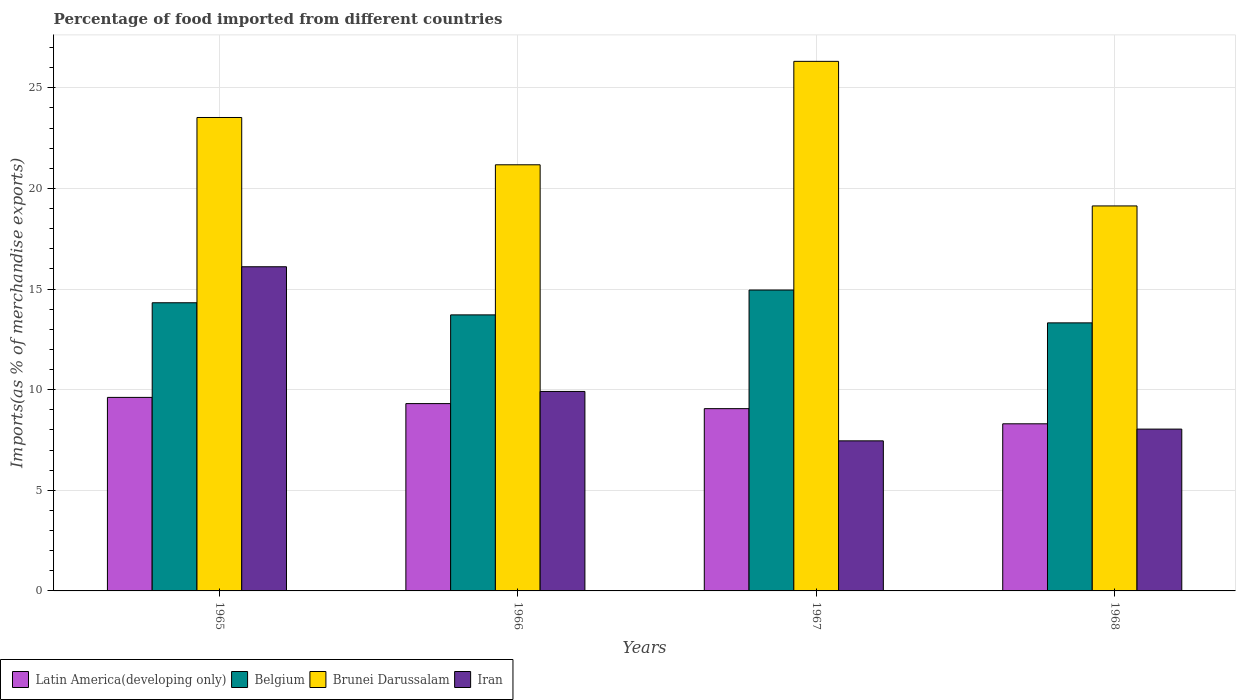How many different coloured bars are there?
Provide a succinct answer. 4. How many groups of bars are there?
Make the answer very short. 4. Are the number of bars on each tick of the X-axis equal?
Your response must be concise. Yes. How many bars are there on the 4th tick from the left?
Keep it short and to the point. 4. How many bars are there on the 4th tick from the right?
Your response must be concise. 4. What is the label of the 3rd group of bars from the left?
Make the answer very short. 1967. In how many cases, is the number of bars for a given year not equal to the number of legend labels?
Offer a terse response. 0. What is the percentage of imports to different countries in Belgium in 1966?
Your response must be concise. 13.72. Across all years, what is the maximum percentage of imports to different countries in Brunei Darussalam?
Your response must be concise. 26.32. Across all years, what is the minimum percentage of imports to different countries in Brunei Darussalam?
Your answer should be very brief. 19.13. In which year was the percentage of imports to different countries in Latin America(developing only) maximum?
Your response must be concise. 1965. In which year was the percentage of imports to different countries in Belgium minimum?
Keep it short and to the point. 1968. What is the total percentage of imports to different countries in Latin America(developing only) in the graph?
Your answer should be very brief. 36.29. What is the difference between the percentage of imports to different countries in Brunei Darussalam in 1965 and that in 1967?
Give a very brief answer. -2.79. What is the difference between the percentage of imports to different countries in Latin America(developing only) in 1968 and the percentage of imports to different countries in Brunei Darussalam in 1967?
Make the answer very short. -18.01. What is the average percentage of imports to different countries in Brunei Darussalam per year?
Your answer should be very brief. 22.54. In the year 1965, what is the difference between the percentage of imports to different countries in Iran and percentage of imports to different countries in Belgium?
Offer a terse response. 1.79. What is the ratio of the percentage of imports to different countries in Brunei Darussalam in 1965 to that in 1966?
Make the answer very short. 1.11. What is the difference between the highest and the second highest percentage of imports to different countries in Belgium?
Keep it short and to the point. 0.63. What is the difference between the highest and the lowest percentage of imports to different countries in Iran?
Provide a short and direct response. 8.65. In how many years, is the percentage of imports to different countries in Belgium greater than the average percentage of imports to different countries in Belgium taken over all years?
Keep it short and to the point. 2. Is it the case that in every year, the sum of the percentage of imports to different countries in Belgium and percentage of imports to different countries in Iran is greater than the sum of percentage of imports to different countries in Latin America(developing only) and percentage of imports to different countries in Brunei Darussalam?
Ensure brevity in your answer.  No. What does the 3rd bar from the left in 1967 represents?
Your answer should be compact. Brunei Darussalam. What does the 4th bar from the right in 1965 represents?
Provide a short and direct response. Latin America(developing only). Is it the case that in every year, the sum of the percentage of imports to different countries in Iran and percentage of imports to different countries in Brunei Darussalam is greater than the percentage of imports to different countries in Belgium?
Your answer should be compact. Yes. What is the difference between two consecutive major ticks on the Y-axis?
Offer a terse response. 5. Does the graph contain any zero values?
Offer a terse response. No. How are the legend labels stacked?
Offer a very short reply. Horizontal. What is the title of the graph?
Give a very brief answer. Percentage of food imported from different countries. What is the label or title of the Y-axis?
Your answer should be compact. Imports(as % of merchandise exports). What is the Imports(as % of merchandise exports) of Latin America(developing only) in 1965?
Your answer should be compact. 9.62. What is the Imports(as % of merchandise exports) in Belgium in 1965?
Give a very brief answer. 14.32. What is the Imports(as % of merchandise exports) of Brunei Darussalam in 1965?
Your response must be concise. 23.53. What is the Imports(as % of merchandise exports) of Iran in 1965?
Provide a short and direct response. 16.11. What is the Imports(as % of merchandise exports) in Latin America(developing only) in 1966?
Provide a succinct answer. 9.31. What is the Imports(as % of merchandise exports) in Belgium in 1966?
Your answer should be compact. 13.72. What is the Imports(as % of merchandise exports) of Brunei Darussalam in 1966?
Your answer should be very brief. 21.18. What is the Imports(as % of merchandise exports) in Iran in 1966?
Your response must be concise. 9.91. What is the Imports(as % of merchandise exports) of Latin America(developing only) in 1967?
Your response must be concise. 9.06. What is the Imports(as % of merchandise exports) in Belgium in 1967?
Offer a very short reply. 14.95. What is the Imports(as % of merchandise exports) of Brunei Darussalam in 1967?
Ensure brevity in your answer.  26.32. What is the Imports(as % of merchandise exports) in Iran in 1967?
Ensure brevity in your answer.  7.46. What is the Imports(as % of merchandise exports) in Latin America(developing only) in 1968?
Ensure brevity in your answer.  8.3. What is the Imports(as % of merchandise exports) in Belgium in 1968?
Provide a succinct answer. 13.32. What is the Imports(as % of merchandise exports) in Brunei Darussalam in 1968?
Provide a succinct answer. 19.13. What is the Imports(as % of merchandise exports) of Iran in 1968?
Give a very brief answer. 8.04. Across all years, what is the maximum Imports(as % of merchandise exports) of Latin America(developing only)?
Make the answer very short. 9.62. Across all years, what is the maximum Imports(as % of merchandise exports) of Belgium?
Keep it short and to the point. 14.95. Across all years, what is the maximum Imports(as % of merchandise exports) in Brunei Darussalam?
Give a very brief answer. 26.32. Across all years, what is the maximum Imports(as % of merchandise exports) of Iran?
Offer a very short reply. 16.11. Across all years, what is the minimum Imports(as % of merchandise exports) of Latin America(developing only)?
Your answer should be very brief. 8.3. Across all years, what is the minimum Imports(as % of merchandise exports) of Belgium?
Your answer should be very brief. 13.32. Across all years, what is the minimum Imports(as % of merchandise exports) of Brunei Darussalam?
Offer a very short reply. 19.13. Across all years, what is the minimum Imports(as % of merchandise exports) in Iran?
Ensure brevity in your answer.  7.46. What is the total Imports(as % of merchandise exports) of Latin America(developing only) in the graph?
Provide a short and direct response. 36.29. What is the total Imports(as % of merchandise exports) of Belgium in the graph?
Your answer should be compact. 56.31. What is the total Imports(as % of merchandise exports) of Brunei Darussalam in the graph?
Offer a terse response. 90.15. What is the total Imports(as % of merchandise exports) in Iran in the graph?
Provide a short and direct response. 41.52. What is the difference between the Imports(as % of merchandise exports) of Latin America(developing only) in 1965 and that in 1966?
Offer a very short reply. 0.31. What is the difference between the Imports(as % of merchandise exports) in Belgium in 1965 and that in 1966?
Provide a short and direct response. 0.6. What is the difference between the Imports(as % of merchandise exports) of Brunei Darussalam in 1965 and that in 1966?
Give a very brief answer. 2.35. What is the difference between the Imports(as % of merchandise exports) in Iran in 1965 and that in 1966?
Your response must be concise. 6.2. What is the difference between the Imports(as % of merchandise exports) of Latin America(developing only) in 1965 and that in 1967?
Offer a very short reply. 0.56. What is the difference between the Imports(as % of merchandise exports) in Belgium in 1965 and that in 1967?
Your answer should be compact. -0.63. What is the difference between the Imports(as % of merchandise exports) in Brunei Darussalam in 1965 and that in 1967?
Make the answer very short. -2.79. What is the difference between the Imports(as % of merchandise exports) in Iran in 1965 and that in 1967?
Your answer should be compact. 8.65. What is the difference between the Imports(as % of merchandise exports) of Latin America(developing only) in 1965 and that in 1968?
Your response must be concise. 1.31. What is the difference between the Imports(as % of merchandise exports) of Belgium in 1965 and that in 1968?
Provide a short and direct response. 1. What is the difference between the Imports(as % of merchandise exports) of Brunei Darussalam in 1965 and that in 1968?
Keep it short and to the point. 4.39. What is the difference between the Imports(as % of merchandise exports) in Iran in 1965 and that in 1968?
Provide a succinct answer. 8.07. What is the difference between the Imports(as % of merchandise exports) of Latin America(developing only) in 1966 and that in 1967?
Provide a short and direct response. 0.25. What is the difference between the Imports(as % of merchandise exports) of Belgium in 1966 and that in 1967?
Keep it short and to the point. -1.24. What is the difference between the Imports(as % of merchandise exports) of Brunei Darussalam in 1966 and that in 1967?
Make the answer very short. -5.14. What is the difference between the Imports(as % of merchandise exports) of Iran in 1966 and that in 1967?
Give a very brief answer. 2.46. What is the difference between the Imports(as % of merchandise exports) of Belgium in 1966 and that in 1968?
Give a very brief answer. 0.4. What is the difference between the Imports(as % of merchandise exports) in Brunei Darussalam in 1966 and that in 1968?
Ensure brevity in your answer.  2.04. What is the difference between the Imports(as % of merchandise exports) of Iran in 1966 and that in 1968?
Your answer should be compact. 1.87. What is the difference between the Imports(as % of merchandise exports) in Latin America(developing only) in 1967 and that in 1968?
Offer a very short reply. 0.75. What is the difference between the Imports(as % of merchandise exports) of Belgium in 1967 and that in 1968?
Your response must be concise. 1.63. What is the difference between the Imports(as % of merchandise exports) in Brunei Darussalam in 1967 and that in 1968?
Provide a short and direct response. 7.18. What is the difference between the Imports(as % of merchandise exports) of Iran in 1967 and that in 1968?
Keep it short and to the point. -0.58. What is the difference between the Imports(as % of merchandise exports) of Latin America(developing only) in 1965 and the Imports(as % of merchandise exports) of Belgium in 1966?
Your response must be concise. -4.1. What is the difference between the Imports(as % of merchandise exports) of Latin America(developing only) in 1965 and the Imports(as % of merchandise exports) of Brunei Darussalam in 1966?
Provide a succinct answer. -11.56. What is the difference between the Imports(as % of merchandise exports) of Latin America(developing only) in 1965 and the Imports(as % of merchandise exports) of Iran in 1966?
Offer a terse response. -0.3. What is the difference between the Imports(as % of merchandise exports) of Belgium in 1965 and the Imports(as % of merchandise exports) of Brunei Darussalam in 1966?
Your response must be concise. -6.86. What is the difference between the Imports(as % of merchandise exports) of Belgium in 1965 and the Imports(as % of merchandise exports) of Iran in 1966?
Ensure brevity in your answer.  4.41. What is the difference between the Imports(as % of merchandise exports) of Brunei Darussalam in 1965 and the Imports(as % of merchandise exports) of Iran in 1966?
Provide a succinct answer. 13.61. What is the difference between the Imports(as % of merchandise exports) in Latin America(developing only) in 1965 and the Imports(as % of merchandise exports) in Belgium in 1967?
Ensure brevity in your answer.  -5.34. What is the difference between the Imports(as % of merchandise exports) of Latin America(developing only) in 1965 and the Imports(as % of merchandise exports) of Brunei Darussalam in 1967?
Make the answer very short. -16.7. What is the difference between the Imports(as % of merchandise exports) in Latin America(developing only) in 1965 and the Imports(as % of merchandise exports) in Iran in 1967?
Provide a short and direct response. 2.16. What is the difference between the Imports(as % of merchandise exports) in Belgium in 1965 and the Imports(as % of merchandise exports) in Brunei Darussalam in 1967?
Your response must be concise. -12. What is the difference between the Imports(as % of merchandise exports) in Belgium in 1965 and the Imports(as % of merchandise exports) in Iran in 1967?
Give a very brief answer. 6.86. What is the difference between the Imports(as % of merchandise exports) of Brunei Darussalam in 1965 and the Imports(as % of merchandise exports) of Iran in 1967?
Your answer should be very brief. 16.07. What is the difference between the Imports(as % of merchandise exports) of Latin America(developing only) in 1965 and the Imports(as % of merchandise exports) of Belgium in 1968?
Keep it short and to the point. -3.7. What is the difference between the Imports(as % of merchandise exports) in Latin America(developing only) in 1965 and the Imports(as % of merchandise exports) in Brunei Darussalam in 1968?
Your response must be concise. -9.51. What is the difference between the Imports(as % of merchandise exports) of Latin America(developing only) in 1965 and the Imports(as % of merchandise exports) of Iran in 1968?
Provide a succinct answer. 1.58. What is the difference between the Imports(as % of merchandise exports) of Belgium in 1965 and the Imports(as % of merchandise exports) of Brunei Darussalam in 1968?
Ensure brevity in your answer.  -4.81. What is the difference between the Imports(as % of merchandise exports) in Belgium in 1965 and the Imports(as % of merchandise exports) in Iran in 1968?
Your response must be concise. 6.28. What is the difference between the Imports(as % of merchandise exports) of Brunei Darussalam in 1965 and the Imports(as % of merchandise exports) of Iran in 1968?
Offer a very short reply. 15.48. What is the difference between the Imports(as % of merchandise exports) in Latin America(developing only) in 1966 and the Imports(as % of merchandise exports) in Belgium in 1967?
Your response must be concise. -5.64. What is the difference between the Imports(as % of merchandise exports) of Latin America(developing only) in 1966 and the Imports(as % of merchandise exports) of Brunei Darussalam in 1967?
Ensure brevity in your answer.  -17.01. What is the difference between the Imports(as % of merchandise exports) of Latin America(developing only) in 1966 and the Imports(as % of merchandise exports) of Iran in 1967?
Offer a very short reply. 1.85. What is the difference between the Imports(as % of merchandise exports) in Belgium in 1966 and the Imports(as % of merchandise exports) in Brunei Darussalam in 1967?
Keep it short and to the point. -12.6. What is the difference between the Imports(as % of merchandise exports) in Belgium in 1966 and the Imports(as % of merchandise exports) in Iran in 1967?
Keep it short and to the point. 6.26. What is the difference between the Imports(as % of merchandise exports) of Brunei Darussalam in 1966 and the Imports(as % of merchandise exports) of Iran in 1967?
Ensure brevity in your answer.  13.72. What is the difference between the Imports(as % of merchandise exports) in Latin America(developing only) in 1966 and the Imports(as % of merchandise exports) in Belgium in 1968?
Ensure brevity in your answer.  -4.01. What is the difference between the Imports(as % of merchandise exports) in Latin America(developing only) in 1966 and the Imports(as % of merchandise exports) in Brunei Darussalam in 1968?
Your answer should be very brief. -9.82. What is the difference between the Imports(as % of merchandise exports) of Latin America(developing only) in 1966 and the Imports(as % of merchandise exports) of Iran in 1968?
Keep it short and to the point. 1.27. What is the difference between the Imports(as % of merchandise exports) in Belgium in 1966 and the Imports(as % of merchandise exports) in Brunei Darussalam in 1968?
Give a very brief answer. -5.41. What is the difference between the Imports(as % of merchandise exports) in Belgium in 1966 and the Imports(as % of merchandise exports) in Iran in 1968?
Offer a terse response. 5.68. What is the difference between the Imports(as % of merchandise exports) in Brunei Darussalam in 1966 and the Imports(as % of merchandise exports) in Iran in 1968?
Provide a succinct answer. 13.13. What is the difference between the Imports(as % of merchandise exports) of Latin America(developing only) in 1967 and the Imports(as % of merchandise exports) of Belgium in 1968?
Offer a terse response. -4.26. What is the difference between the Imports(as % of merchandise exports) in Latin America(developing only) in 1967 and the Imports(as % of merchandise exports) in Brunei Darussalam in 1968?
Provide a short and direct response. -10.07. What is the difference between the Imports(as % of merchandise exports) of Latin America(developing only) in 1967 and the Imports(as % of merchandise exports) of Iran in 1968?
Your response must be concise. 1.02. What is the difference between the Imports(as % of merchandise exports) of Belgium in 1967 and the Imports(as % of merchandise exports) of Brunei Darussalam in 1968?
Your response must be concise. -4.18. What is the difference between the Imports(as % of merchandise exports) of Belgium in 1967 and the Imports(as % of merchandise exports) of Iran in 1968?
Give a very brief answer. 6.91. What is the difference between the Imports(as % of merchandise exports) in Brunei Darussalam in 1967 and the Imports(as % of merchandise exports) in Iran in 1968?
Offer a terse response. 18.27. What is the average Imports(as % of merchandise exports) of Latin America(developing only) per year?
Your answer should be very brief. 9.07. What is the average Imports(as % of merchandise exports) of Belgium per year?
Provide a short and direct response. 14.08. What is the average Imports(as % of merchandise exports) in Brunei Darussalam per year?
Give a very brief answer. 22.54. What is the average Imports(as % of merchandise exports) of Iran per year?
Provide a succinct answer. 10.38. In the year 1965, what is the difference between the Imports(as % of merchandise exports) in Latin America(developing only) and Imports(as % of merchandise exports) in Belgium?
Offer a terse response. -4.7. In the year 1965, what is the difference between the Imports(as % of merchandise exports) in Latin America(developing only) and Imports(as % of merchandise exports) in Brunei Darussalam?
Your answer should be compact. -13.91. In the year 1965, what is the difference between the Imports(as % of merchandise exports) of Latin America(developing only) and Imports(as % of merchandise exports) of Iran?
Provide a short and direct response. -6.49. In the year 1965, what is the difference between the Imports(as % of merchandise exports) in Belgium and Imports(as % of merchandise exports) in Brunei Darussalam?
Offer a terse response. -9.21. In the year 1965, what is the difference between the Imports(as % of merchandise exports) of Belgium and Imports(as % of merchandise exports) of Iran?
Your answer should be compact. -1.79. In the year 1965, what is the difference between the Imports(as % of merchandise exports) in Brunei Darussalam and Imports(as % of merchandise exports) in Iran?
Your answer should be compact. 7.42. In the year 1966, what is the difference between the Imports(as % of merchandise exports) in Latin America(developing only) and Imports(as % of merchandise exports) in Belgium?
Your answer should be compact. -4.41. In the year 1966, what is the difference between the Imports(as % of merchandise exports) of Latin America(developing only) and Imports(as % of merchandise exports) of Brunei Darussalam?
Your response must be concise. -11.87. In the year 1966, what is the difference between the Imports(as % of merchandise exports) in Latin America(developing only) and Imports(as % of merchandise exports) in Iran?
Keep it short and to the point. -0.6. In the year 1966, what is the difference between the Imports(as % of merchandise exports) in Belgium and Imports(as % of merchandise exports) in Brunei Darussalam?
Make the answer very short. -7.46. In the year 1966, what is the difference between the Imports(as % of merchandise exports) in Belgium and Imports(as % of merchandise exports) in Iran?
Your answer should be very brief. 3.8. In the year 1966, what is the difference between the Imports(as % of merchandise exports) of Brunei Darussalam and Imports(as % of merchandise exports) of Iran?
Your answer should be very brief. 11.26. In the year 1967, what is the difference between the Imports(as % of merchandise exports) in Latin America(developing only) and Imports(as % of merchandise exports) in Belgium?
Your response must be concise. -5.89. In the year 1967, what is the difference between the Imports(as % of merchandise exports) of Latin America(developing only) and Imports(as % of merchandise exports) of Brunei Darussalam?
Give a very brief answer. -17.26. In the year 1967, what is the difference between the Imports(as % of merchandise exports) of Latin America(developing only) and Imports(as % of merchandise exports) of Iran?
Your answer should be very brief. 1.6. In the year 1967, what is the difference between the Imports(as % of merchandise exports) of Belgium and Imports(as % of merchandise exports) of Brunei Darussalam?
Ensure brevity in your answer.  -11.36. In the year 1967, what is the difference between the Imports(as % of merchandise exports) in Belgium and Imports(as % of merchandise exports) in Iran?
Your answer should be very brief. 7.5. In the year 1967, what is the difference between the Imports(as % of merchandise exports) in Brunei Darussalam and Imports(as % of merchandise exports) in Iran?
Your answer should be compact. 18.86. In the year 1968, what is the difference between the Imports(as % of merchandise exports) of Latin America(developing only) and Imports(as % of merchandise exports) of Belgium?
Your answer should be compact. -5.02. In the year 1968, what is the difference between the Imports(as % of merchandise exports) in Latin America(developing only) and Imports(as % of merchandise exports) in Brunei Darussalam?
Ensure brevity in your answer.  -10.83. In the year 1968, what is the difference between the Imports(as % of merchandise exports) of Latin America(developing only) and Imports(as % of merchandise exports) of Iran?
Make the answer very short. 0.26. In the year 1968, what is the difference between the Imports(as % of merchandise exports) of Belgium and Imports(as % of merchandise exports) of Brunei Darussalam?
Your response must be concise. -5.81. In the year 1968, what is the difference between the Imports(as % of merchandise exports) of Belgium and Imports(as % of merchandise exports) of Iran?
Your response must be concise. 5.28. In the year 1968, what is the difference between the Imports(as % of merchandise exports) in Brunei Darussalam and Imports(as % of merchandise exports) in Iran?
Ensure brevity in your answer.  11.09. What is the ratio of the Imports(as % of merchandise exports) of Latin America(developing only) in 1965 to that in 1966?
Ensure brevity in your answer.  1.03. What is the ratio of the Imports(as % of merchandise exports) of Belgium in 1965 to that in 1966?
Provide a succinct answer. 1.04. What is the ratio of the Imports(as % of merchandise exports) in Brunei Darussalam in 1965 to that in 1966?
Your answer should be compact. 1.11. What is the ratio of the Imports(as % of merchandise exports) in Iran in 1965 to that in 1966?
Your response must be concise. 1.62. What is the ratio of the Imports(as % of merchandise exports) of Latin America(developing only) in 1965 to that in 1967?
Your response must be concise. 1.06. What is the ratio of the Imports(as % of merchandise exports) of Belgium in 1965 to that in 1967?
Your answer should be compact. 0.96. What is the ratio of the Imports(as % of merchandise exports) in Brunei Darussalam in 1965 to that in 1967?
Give a very brief answer. 0.89. What is the ratio of the Imports(as % of merchandise exports) of Iran in 1965 to that in 1967?
Give a very brief answer. 2.16. What is the ratio of the Imports(as % of merchandise exports) in Latin America(developing only) in 1965 to that in 1968?
Ensure brevity in your answer.  1.16. What is the ratio of the Imports(as % of merchandise exports) of Belgium in 1965 to that in 1968?
Provide a short and direct response. 1.07. What is the ratio of the Imports(as % of merchandise exports) of Brunei Darussalam in 1965 to that in 1968?
Your answer should be compact. 1.23. What is the ratio of the Imports(as % of merchandise exports) of Iran in 1965 to that in 1968?
Offer a very short reply. 2. What is the ratio of the Imports(as % of merchandise exports) of Latin America(developing only) in 1966 to that in 1967?
Provide a succinct answer. 1.03. What is the ratio of the Imports(as % of merchandise exports) in Belgium in 1966 to that in 1967?
Your response must be concise. 0.92. What is the ratio of the Imports(as % of merchandise exports) of Brunei Darussalam in 1966 to that in 1967?
Give a very brief answer. 0.8. What is the ratio of the Imports(as % of merchandise exports) of Iran in 1966 to that in 1967?
Your response must be concise. 1.33. What is the ratio of the Imports(as % of merchandise exports) in Latin America(developing only) in 1966 to that in 1968?
Your response must be concise. 1.12. What is the ratio of the Imports(as % of merchandise exports) in Belgium in 1966 to that in 1968?
Your response must be concise. 1.03. What is the ratio of the Imports(as % of merchandise exports) in Brunei Darussalam in 1966 to that in 1968?
Ensure brevity in your answer.  1.11. What is the ratio of the Imports(as % of merchandise exports) in Iran in 1966 to that in 1968?
Keep it short and to the point. 1.23. What is the ratio of the Imports(as % of merchandise exports) in Latin America(developing only) in 1967 to that in 1968?
Provide a succinct answer. 1.09. What is the ratio of the Imports(as % of merchandise exports) in Belgium in 1967 to that in 1968?
Give a very brief answer. 1.12. What is the ratio of the Imports(as % of merchandise exports) of Brunei Darussalam in 1967 to that in 1968?
Ensure brevity in your answer.  1.38. What is the ratio of the Imports(as % of merchandise exports) of Iran in 1967 to that in 1968?
Keep it short and to the point. 0.93. What is the difference between the highest and the second highest Imports(as % of merchandise exports) in Latin America(developing only)?
Offer a terse response. 0.31. What is the difference between the highest and the second highest Imports(as % of merchandise exports) in Belgium?
Your answer should be compact. 0.63. What is the difference between the highest and the second highest Imports(as % of merchandise exports) of Brunei Darussalam?
Offer a terse response. 2.79. What is the difference between the highest and the second highest Imports(as % of merchandise exports) in Iran?
Your answer should be very brief. 6.2. What is the difference between the highest and the lowest Imports(as % of merchandise exports) of Latin America(developing only)?
Your answer should be compact. 1.31. What is the difference between the highest and the lowest Imports(as % of merchandise exports) of Belgium?
Make the answer very short. 1.63. What is the difference between the highest and the lowest Imports(as % of merchandise exports) in Brunei Darussalam?
Make the answer very short. 7.18. What is the difference between the highest and the lowest Imports(as % of merchandise exports) of Iran?
Your answer should be very brief. 8.65. 